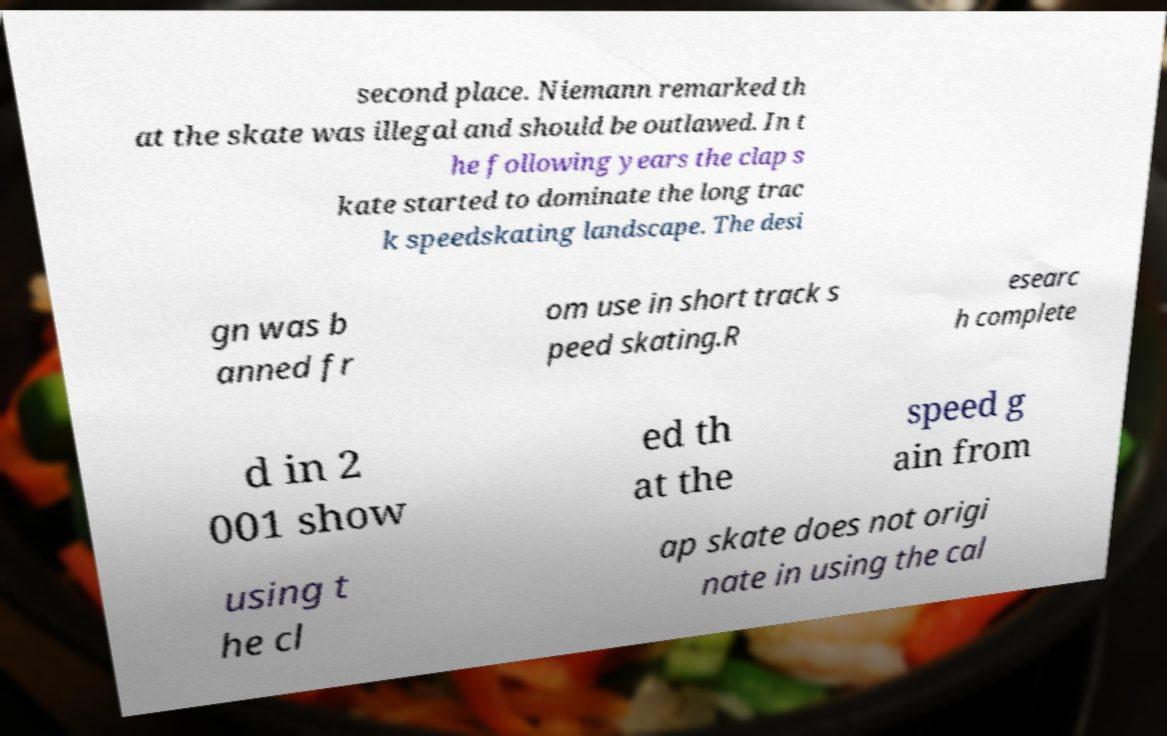Can you read and provide the text displayed in the image?This photo seems to have some interesting text. Can you extract and type it out for me? second place. Niemann remarked th at the skate was illegal and should be outlawed. In t he following years the clap s kate started to dominate the long trac k speedskating landscape. The desi gn was b anned fr om use in short track s peed skating.R esearc h complete d in 2 001 show ed th at the speed g ain from using t he cl ap skate does not origi nate in using the cal 